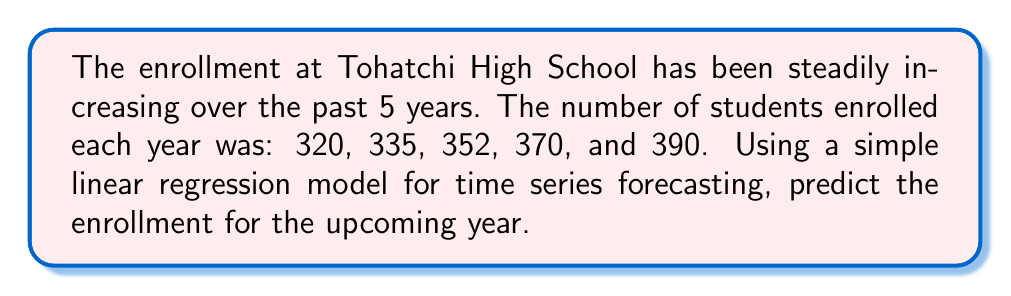Can you answer this question? To predict the enrollment using simple linear regression, we'll follow these steps:

1. Assign time values (x) to each year: 1, 2, 3, 4, 5
2. Set up the enrollment numbers (y): 320, 335, 352, 370, 390
3. Calculate the means: $\bar{x} = 3$ and $\bar{y} = 353.4$
4. Calculate the slope (m) using the formula:

   $$m = \frac{\sum_{i=1}^{n} (x_i - \bar{x})(y_i - \bar{y})}{\sum_{i=1}^{n} (x_i - \bar{x})^2}$$

5. Calculate the y-intercept (b) using: $b = \bar{y} - m\bar{x}$
6. Use the equation $y = mx + b$ to predict the enrollment for year 6

Step 4: Calculating the slope
$$m = \frac{(1-3)(320-353.4) + (2-3)(335-353.4) + ... + (5-3)(390-353.4)}{(1-3)^2 + (2-3)^2 + (3-3)^2 + (4-3)^2 + (5-3)^2}$$
$$m = \frac{700}{10} = 70$$

Step 5: Calculating the y-intercept
$$b = 353.4 - 70(3) = 143.4$$

Step 6: Predicting enrollment for year 6
$$y = 70x + 143.4$$
$$y = 70(6) + 143.4 = 563.4$$

Therefore, the predicted enrollment for the upcoming year is approximately 563 students.
Answer: 563 students 